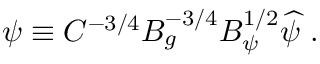Convert formula to latex. <formula><loc_0><loc_0><loc_500><loc_500>\psi \equiv C ^ { - 3 / 4 } B _ { g } ^ { - 3 / 4 } B _ { \psi } ^ { 1 / 2 } \widehat { \psi } \ .</formula> 